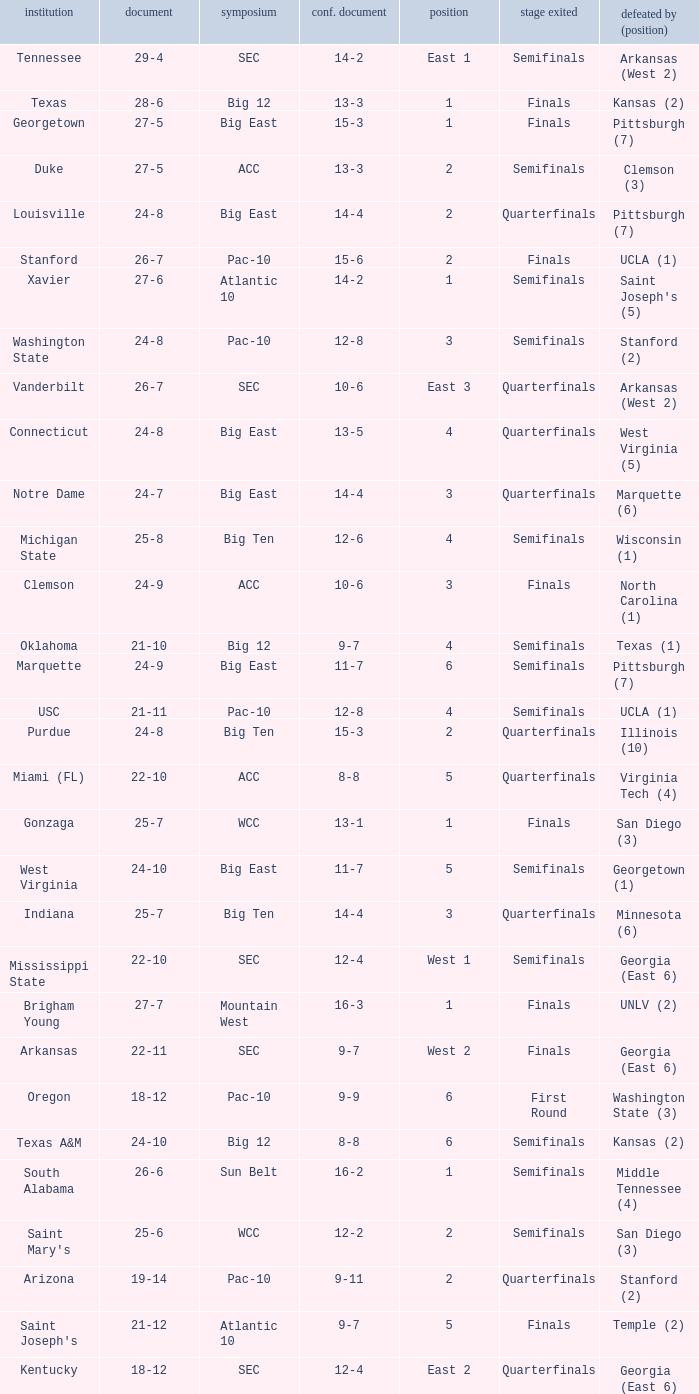Name the conference record where seed is 3 and record is 24-9 10-6. 